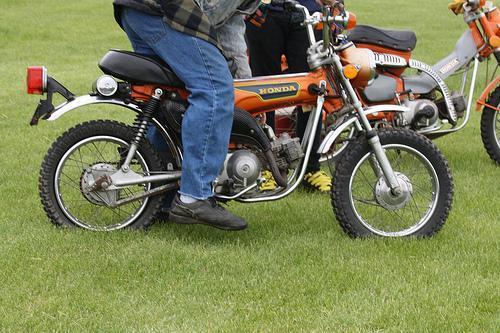How many motorcycles are in the photo?
Give a very brief answer. 2. 